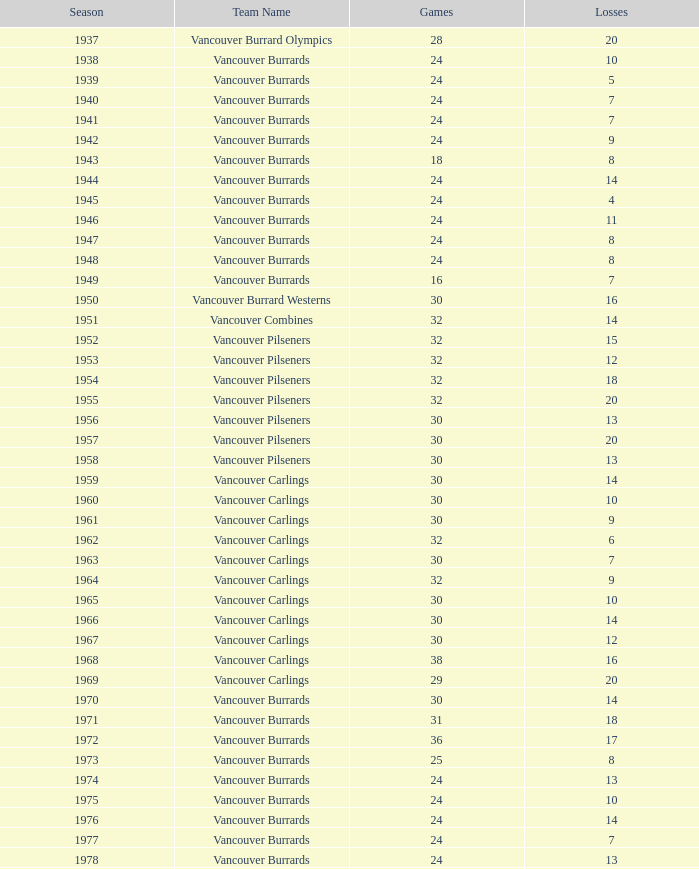What's the combined points for the 1963 season when there are more than 30 games? None. 